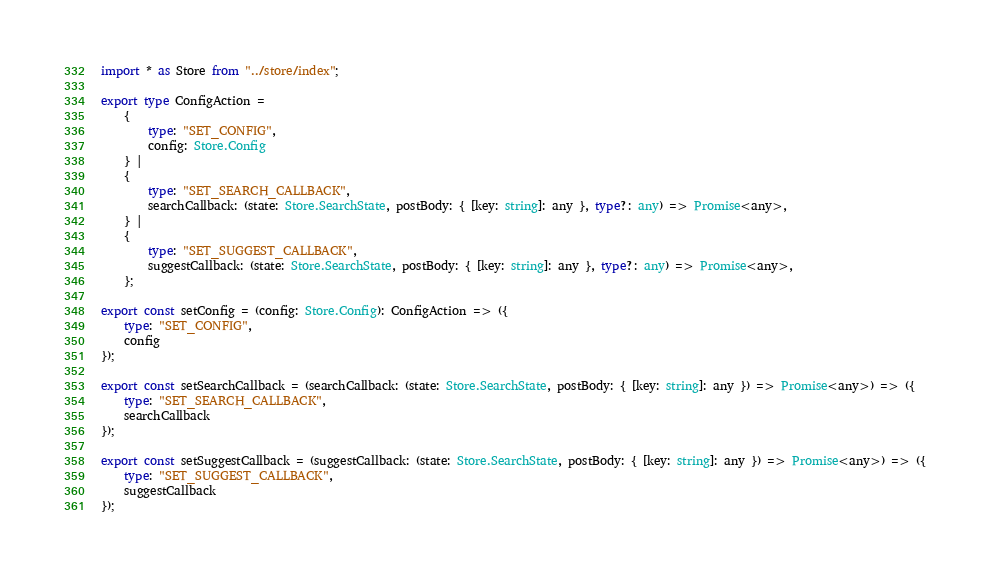Convert code to text. <code><loc_0><loc_0><loc_500><loc_500><_TypeScript_>import * as Store from "../store/index";

export type ConfigAction =
    {
        type: "SET_CONFIG",
        config: Store.Config
    } |
    {
        type: "SET_SEARCH_CALLBACK",
        searchCallback: (state: Store.SearchState, postBody: { [key: string]: any }, type?: any) => Promise<any>,
    } |
    {
        type: "SET_SUGGEST_CALLBACK",
        suggestCallback: (state: Store.SearchState, postBody: { [key: string]: any }, type?: any) => Promise<any>,
    };

export const setConfig = (config: Store.Config): ConfigAction => ({
    type: "SET_CONFIG",
    config
});

export const setSearchCallback = (searchCallback: (state: Store.SearchState, postBody: { [key: string]: any }) => Promise<any>) => ({
    type: "SET_SEARCH_CALLBACK",
    searchCallback
});

export const setSuggestCallback = (suggestCallback: (state: Store.SearchState, postBody: { [key: string]: any }) => Promise<any>) => ({
    type: "SET_SUGGEST_CALLBACK",
    suggestCallback
});
</code> 